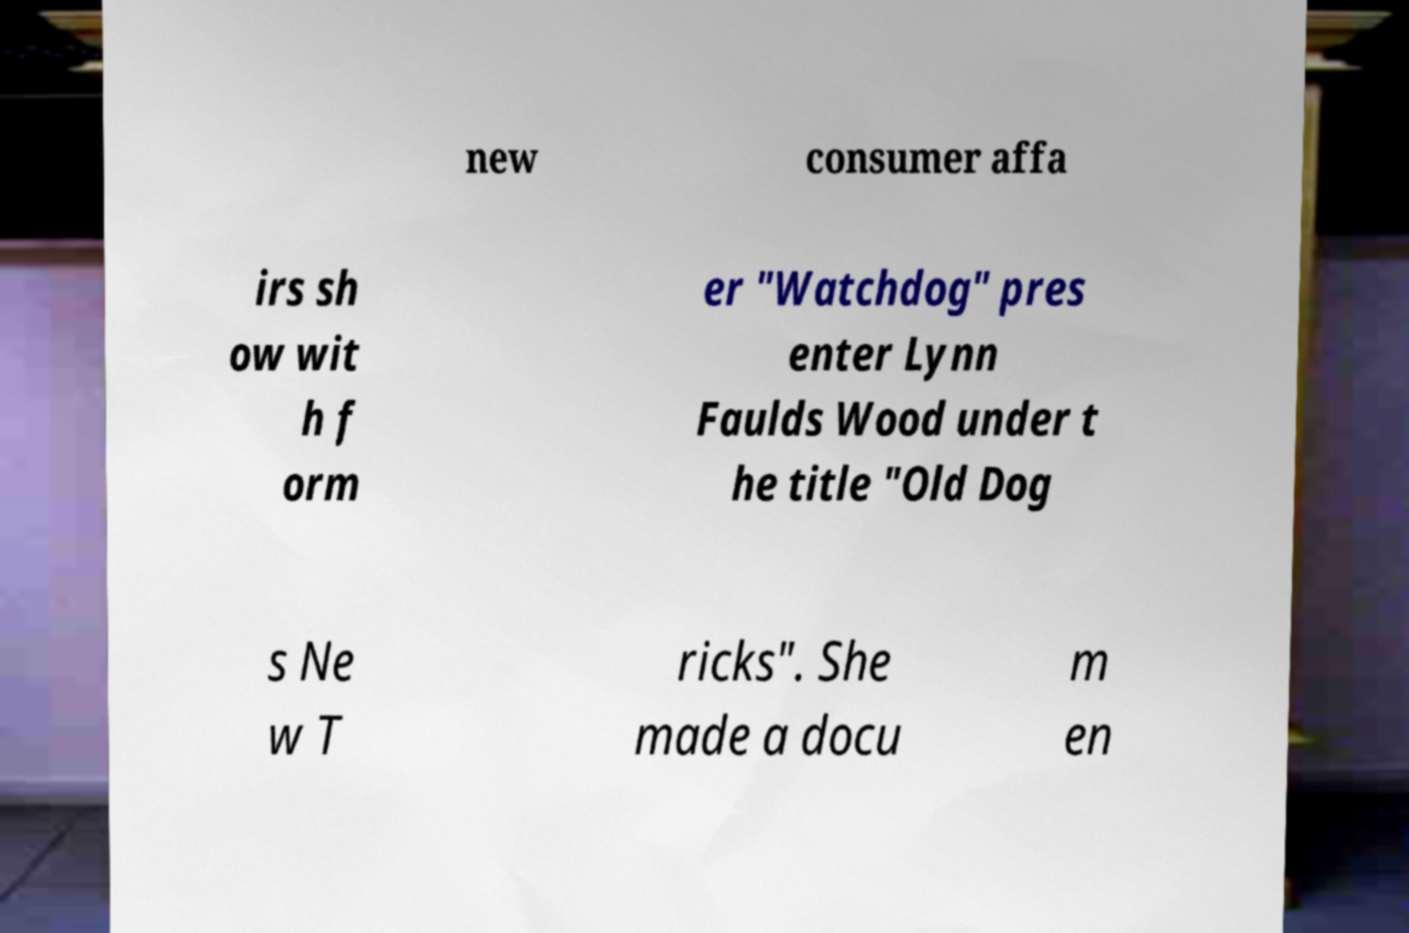Please read and relay the text visible in this image. What does it say? new consumer affa irs sh ow wit h f orm er "Watchdog" pres enter Lynn Faulds Wood under t he title "Old Dog s Ne w T ricks". She made a docu m en 